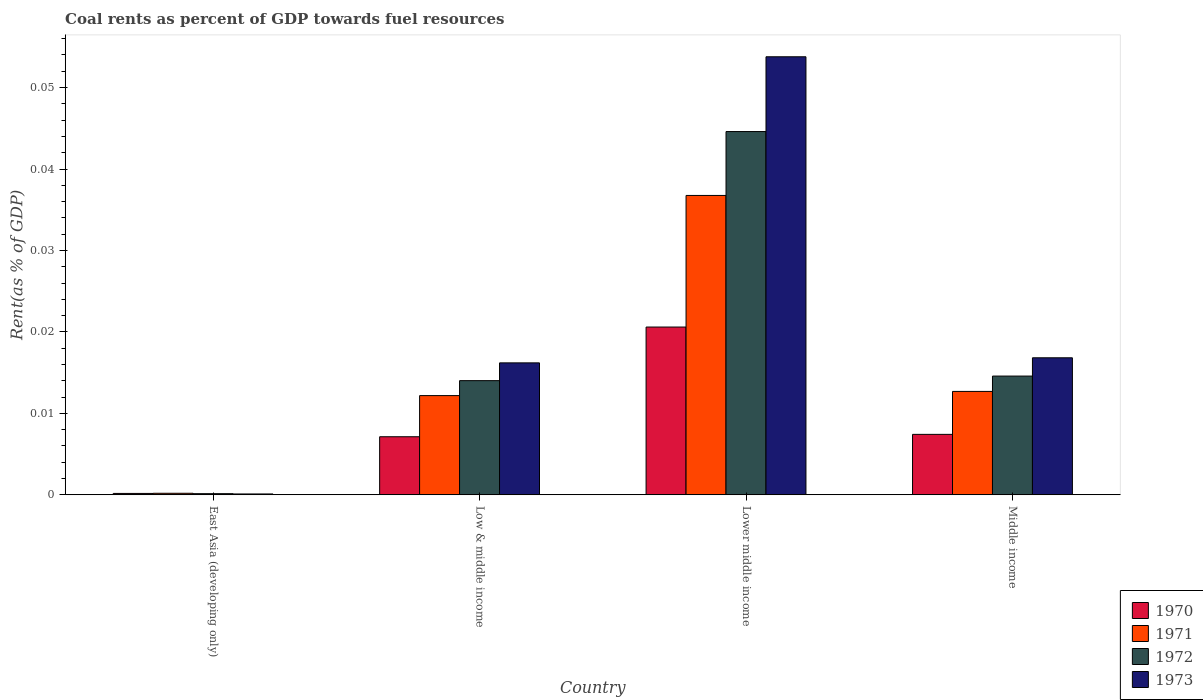Are the number of bars on each tick of the X-axis equal?
Offer a very short reply. Yes. How many bars are there on the 2nd tick from the left?
Keep it short and to the point. 4. How many bars are there on the 2nd tick from the right?
Provide a succinct answer. 4. What is the label of the 4th group of bars from the left?
Keep it short and to the point. Middle income. In how many cases, is the number of bars for a given country not equal to the number of legend labels?
Your answer should be compact. 0. What is the coal rent in 1971 in Middle income?
Give a very brief answer. 0.01. Across all countries, what is the maximum coal rent in 1972?
Ensure brevity in your answer.  0.04. Across all countries, what is the minimum coal rent in 1970?
Your answer should be compact. 0. In which country was the coal rent in 1971 maximum?
Your response must be concise. Lower middle income. In which country was the coal rent in 1971 minimum?
Offer a terse response. East Asia (developing only). What is the total coal rent in 1970 in the graph?
Provide a succinct answer. 0.04. What is the difference between the coal rent in 1973 in Low & middle income and that in Lower middle income?
Provide a short and direct response. -0.04. What is the difference between the coal rent in 1970 in Lower middle income and the coal rent in 1973 in Middle income?
Provide a short and direct response. 0. What is the average coal rent in 1972 per country?
Give a very brief answer. 0.02. What is the difference between the coal rent of/in 1972 and coal rent of/in 1971 in Low & middle income?
Keep it short and to the point. 0. What is the ratio of the coal rent in 1972 in East Asia (developing only) to that in Lower middle income?
Offer a very short reply. 0. What is the difference between the highest and the second highest coal rent in 1972?
Your response must be concise. 0.03. What is the difference between the highest and the lowest coal rent in 1972?
Provide a succinct answer. 0.04. In how many countries, is the coal rent in 1971 greater than the average coal rent in 1971 taken over all countries?
Keep it short and to the point. 1. What does the 3rd bar from the right in Middle income represents?
Make the answer very short. 1971. How many bars are there?
Provide a succinct answer. 16. Are all the bars in the graph horizontal?
Give a very brief answer. No. What is the difference between two consecutive major ticks on the Y-axis?
Make the answer very short. 0.01. Are the values on the major ticks of Y-axis written in scientific E-notation?
Keep it short and to the point. No. Does the graph contain any zero values?
Your answer should be compact. No. Where does the legend appear in the graph?
Give a very brief answer. Bottom right. What is the title of the graph?
Provide a short and direct response. Coal rents as percent of GDP towards fuel resources. Does "2010" appear as one of the legend labels in the graph?
Keep it short and to the point. No. What is the label or title of the Y-axis?
Give a very brief answer. Rent(as % of GDP). What is the Rent(as % of GDP) in 1970 in East Asia (developing only)?
Make the answer very short. 0. What is the Rent(as % of GDP) of 1971 in East Asia (developing only)?
Keep it short and to the point. 0. What is the Rent(as % of GDP) of 1972 in East Asia (developing only)?
Give a very brief answer. 0. What is the Rent(as % of GDP) in 1973 in East Asia (developing only)?
Provide a succinct answer. 0. What is the Rent(as % of GDP) of 1970 in Low & middle income?
Your response must be concise. 0.01. What is the Rent(as % of GDP) in 1971 in Low & middle income?
Make the answer very short. 0.01. What is the Rent(as % of GDP) in 1972 in Low & middle income?
Make the answer very short. 0.01. What is the Rent(as % of GDP) in 1973 in Low & middle income?
Give a very brief answer. 0.02. What is the Rent(as % of GDP) of 1970 in Lower middle income?
Offer a very short reply. 0.02. What is the Rent(as % of GDP) in 1971 in Lower middle income?
Offer a very short reply. 0.04. What is the Rent(as % of GDP) of 1972 in Lower middle income?
Your answer should be compact. 0.04. What is the Rent(as % of GDP) of 1973 in Lower middle income?
Keep it short and to the point. 0.05. What is the Rent(as % of GDP) of 1970 in Middle income?
Your answer should be compact. 0.01. What is the Rent(as % of GDP) in 1971 in Middle income?
Provide a short and direct response. 0.01. What is the Rent(as % of GDP) of 1972 in Middle income?
Give a very brief answer. 0.01. What is the Rent(as % of GDP) of 1973 in Middle income?
Your answer should be compact. 0.02. Across all countries, what is the maximum Rent(as % of GDP) in 1970?
Your response must be concise. 0.02. Across all countries, what is the maximum Rent(as % of GDP) of 1971?
Your answer should be compact. 0.04. Across all countries, what is the maximum Rent(as % of GDP) of 1972?
Provide a succinct answer. 0.04. Across all countries, what is the maximum Rent(as % of GDP) in 1973?
Ensure brevity in your answer.  0.05. Across all countries, what is the minimum Rent(as % of GDP) of 1970?
Your answer should be compact. 0. Across all countries, what is the minimum Rent(as % of GDP) of 1971?
Give a very brief answer. 0. Across all countries, what is the minimum Rent(as % of GDP) in 1972?
Your answer should be compact. 0. Across all countries, what is the minimum Rent(as % of GDP) in 1973?
Your answer should be compact. 0. What is the total Rent(as % of GDP) of 1970 in the graph?
Offer a very short reply. 0.04. What is the total Rent(as % of GDP) of 1971 in the graph?
Give a very brief answer. 0.06. What is the total Rent(as % of GDP) in 1972 in the graph?
Provide a short and direct response. 0.07. What is the total Rent(as % of GDP) in 1973 in the graph?
Your answer should be compact. 0.09. What is the difference between the Rent(as % of GDP) of 1970 in East Asia (developing only) and that in Low & middle income?
Make the answer very short. -0.01. What is the difference between the Rent(as % of GDP) in 1971 in East Asia (developing only) and that in Low & middle income?
Offer a very short reply. -0.01. What is the difference between the Rent(as % of GDP) in 1972 in East Asia (developing only) and that in Low & middle income?
Provide a short and direct response. -0.01. What is the difference between the Rent(as % of GDP) in 1973 in East Asia (developing only) and that in Low & middle income?
Make the answer very short. -0.02. What is the difference between the Rent(as % of GDP) of 1970 in East Asia (developing only) and that in Lower middle income?
Provide a short and direct response. -0.02. What is the difference between the Rent(as % of GDP) in 1971 in East Asia (developing only) and that in Lower middle income?
Provide a short and direct response. -0.04. What is the difference between the Rent(as % of GDP) of 1972 in East Asia (developing only) and that in Lower middle income?
Offer a terse response. -0.04. What is the difference between the Rent(as % of GDP) in 1973 in East Asia (developing only) and that in Lower middle income?
Give a very brief answer. -0.05. What is the difference between the Rent(as % of GDP) of 1970 in East Asia (developing only) and that in Middle income?
Keep it short and to the point. -0.01. What is the difference between the Rent(as % of GDP) in 1971 in East Asia (developing only) and that in Middle income?
Provide a succinct answer. -0.01. What is the difference between the Rent(as % of GDP) in 1972 in East Asia (developing only) and that in Middle income?
Provide a succinct answer. -0.01. What is the difference between the Rent(as % of GDP) of 1973 in East Asia (developing only) and that in Middle income?
Your response must be concise. -0.02. What is the difference between the Rent(as % of GDP) in 1970 in Low & middle income and that in Lower middle income?
Keep it short and to the point. -0.01. What is the difference between the Rent(as % of GDP) of 1971 in Low & middle income and that in Lower middle income?
Your answer should be compact. -0.02. What is the difference between the Rent(as % of GDP) in 1972 in Low & middle income and that in Lower middle income?
Ensure brevity in your answer.  -0.03. What is the difference between the Rent(as % of GDP) in 1973 in Low & middle income and that in Lower middle income?
Your answer should be very brief. -0.04. What is the difference between the Rent(as % of GDP) in 1970 in Low & middle income and that in Middle income?
Keep it short and to the point. -0. What is the difference between the Rent(as % of GDP) of 1971 in Low & middle income and that in Middle income?
Ensure brevity in your answer.  -0. What is the difference between the Rent(as % of GDP) in 1972 in Low & middle income and that in Middle income?
Make the answer very short. -0. What is the difference between the Rent(as % of GDP) of 1973 in Low & middle income and that in Middle income?
Your answer should be very brief. -0. What is the difference between the Rent(as % of GDP) in 1970 in Lower middle income and that in Middle income?
Provide a short and direct response. 0.01. What is the difference between the Rent(as % of GDP) of 1971 in Lower middle income and that in Middle income?
Provide a succinct answer. 0.02. What is the difference between the Rent(as % of GDP) of 1972 in Lower middle income and that in Middle income?
Provide a succinct answer. 0.03. What is the difference between the Rent(as % of GDP) of 1973 in Lower middle income and that in Middle income?
Offer a terse response. 0.04. What is the difference between the Rent(as % of GDP) of 1970 in East Asia (developing only) and the Rent(as % of GDP) of 1971 in Low & middle income?
Your answer should be very brief. -0.01. What is the difference between the Rent(as % of GDP) in 1970 in East Asia (developing only) and the Rent(as % of GDP) in 1972 in Low & middle income?
Provide a short and direct response. -0.01. What is the difference between the Rent(as % of GDP) of 1970 in East Asia (developing only) and the Rent(as % of GDP) of 1973 in Low & middle income?
Provide a succinct answer. -0.02. What is the difference between the Rent(as % of GDP) of 1971 in East Asia (developing only) and the Rent(as % of GDP) of 1972 in Low & middle income?
Your answer should be very brief. -0.01. What is the difference between the Rent(as % of GDP) in 1971 in East Asia (developing only) and the Rent(as % of GDP) in 1973 in Low & middle income?
Provide a short and direct response. -0.02. What is the difference between the Rent(as % of GDP) in 1972 in East Asia (developing only) and the Rent(as % of GDP) in 1973 in Low & middle income?
Your answer should be compact. -0.02. What is the difference between the Rent(as % of GDP) in 1970 in East Asia (developing only) and the Rent(as % of GDP) in 1971 in Lower middle income?
Give a very brief answer. -0.04. What is the difference between the Rent(as % of GDP) in 1970 in East Asia (developing only) and the Rent(as % of GDP) in 1972 in Lower middle income?
Provide a short and direct response. -0.04. What is the difference between the Rent(as % of GDP) in 1970 in East Asia (developing only) and the Rent(as % of GDP) in 1973 in Lower middle income?
Ensure brevity in your answer.  -0.05. What is the difference between the Rent(as % of GDP) of 1971 in East Asia (developing only) and the Rent(as % of GDP) of 1972 in Lower middle income?
Your response must be concise. -0.04. What is the difference between the Rent(as % of GDP) of 1971 in East Asia (developing only) and the Rent(as % of GDP) of 1973 in Lower middle income?
Give a very brief answer. -0.05. What is the difference between the Rent(as % of GDP) of 1972 in East Asia (developing only) and the Rent(as % of GDP) of 1973 in Lower middle income?
Your response must be concise. -0.05. What is the difference between the Rent(as % of GDP) of 1970 in East Asia (developing only) and the Rent(as % of GDP) of 1971 in Middle income?
Your answer should be very brief. -0.01. What is the difference between the Rent(as % of GDP) of 1970 in East Asia (developing only) and the Rent(as % of GDP) of 1972 in Middle income?
Provide a short and direct response. -0.01. What is the difference between the Rent(as % of GDP) in 1970 in East Asia (developing only) and the Rent(as % of GDP) in 1973 in Middle income?
Ensure brevity in your answer.  -0.02. What is the difference between the Rent(as % of GDP) of 1971 in East Asia (developing only) and the Rent(as % of GDP) of 1972 in Middle income?
Your response must be concise. -0.01. What is the difference between the Rent(as % of GDP) in 1971 in East Asia (developing only) and the Rent(as % of GDP) in 1973 in Middle income?
Ensure brevity in your answer.  -0.02. What is the difference between the Rent(as % of GDP) in 1972 in East Asia (developing only) and the Rent(as % of GDP) in 1973 in Middle income?
Provide a succinct answer. -0.02. What is the difference between the Rent(as % of GDP) of 1970 in Low & middle income and the Rent(as % of GDP) of 1971 in Lower middle income?
Ensure brevity in your answer.  -0.03. What is the difference between the Rent(as % of GDP) in 1970 in Low & middle income and the Rent(as % of GDP) in 1972 in Lower middle income?
Provide a succinct answer. -0.04. What is the difference between the Rent(as % of GDP) of 1970 in Low & middle income and the Rent(as % of GDP) of 1973 in Lower middle income?
Offer a very short reply. -0.05. What is the difference between the Rent(as % of GDP) of 1971 in Low & middle income and the Rent(as % of GDP) of 1972 in Lower middle income?
Your answer should be compact. -0.03. What is the difference between the Rent(as % of GDP) in 1971 in Low & middle income and the Rent(as % of GDP) in 1973 in Lower middle income?
Your answer should be compact. -0.04. What is the difference between the Rent(as % of GDP) of 1972 in Low & middle income and the Rent(as % of GDP) of 1973 in Lower middle income?
Ensure brevity in your answer.  -0.04. What is the difference between the Rent(as % of GDP) of 1970 in Low & middle income and the Rent(as % of GDP) of 1971 in Middle income?
Give a very brief answer. -0.01. What is the difference between the Rent(as % of GDP) of 1970 in Low & middle income and the Rent(as % of GDP) of 1972 in Middle income?
Keep it short and to the point. -0.01. What is the difference between the Rent(as % of GDP) of 1970 in Low & middle income and the Rent(as % of GDP) of 1973 in Middle income?
Offer a terse response. -0.01. What is the difference between the Rent(as % of GDP) of 1971 in Low & middle income and the Rent(as % of GDP) of 1972 in Middle income?
Your answer should be compact. -0. What is the difference between the Rent(as % of GDP) of 1971 in Low & middle income and the Rent(as % of GDP) of 1973 in Middle income?
Provide a succinct answer. -0. What is the difference between the Rent(as % of GDP) of 1972 in Low & middle income and the Rent(as % of GDP) of 1973 in Middle income?
Your response must be concise. -0. What is the difference between the Rent(as % of GDP) in 1970 in Lower middle income and the Rent(as % of GDP) in 1971 in Middle income?
Ensure brevity in your answer.  0.01. What is the difference between the Rent(as % of GDP) of 1970 in Lower middle income and the Rent(as % of GDP) of 1972 in Middle income?
Your response must be concise. 0.01. What is the difference between the Rent(as % of GDP) of 1970 in Lower middle income and the Rent(as % of GDP) of 1973 in Middle income?
Make the answer very short. 0. What is the difference between the Rent(as % of GDP) of 1971 in Lower middle income and the Rent(as % of GDP) of 1972 in Middle income?
Your answer should be very brief. 0.02. What is the difference between the Rent(as % of GDP) of 1971 in Lower middle income and the Rent(as % of GDP) of 1973 in Middle income?
Provide a short and direct response. 0.02. What is the difference between the Rent(as % of GDP) of 1972 in Lower middle income and the Rent(as % of GDP) of 1973 in Middle income?
Offer a very short reply. 0.03. What is the average Rent(as % of GDP) in 1970 per country?
Give a very brief answer. 0.01. What is the average Rent(as % of GDP) of 1971 per country?
Your answer should be very brief. 0.02. What is the average Rent(as % of GDP) in 1972 per country?
Offer a very short reply. 0.02. What is the average Rent(as % of GDP) of 1973 per country?
Provide a short and direct response. 0.02. What is the difference between the Rent(as % of GDP) in 1970 and Rent(as % of GDP) in 1971 in East Asia (developing only)?
Provide a succinct answer. -0. What is the difference between the Rent(as % of GDP) in 1970 and Rent(as % of GDP) in 1972 in East Asia (developing only)?
Give a very brief answer. 0. What is the difference between the Rent(as % of GDP) in 1970 and Rent(as % of GDP) in 1973 in East Asia (developing only)?
Give a very brief answer. 0. What is the difference between the Rent(as % of GDP) in 1971 and Rent(as % of GDP) in 1973 in East Asia (developing only)?
Your answer should be very brief. 0. What is the difference between the Rent(as % of GDP) in 1972 and Rent(as % of GDP) in 1973 in East Asia (developing only)?
Make the answer very short. 0. What is the difference between the Rent(as % of GDP) of 1970 and Rent(as % of GDP) of 1971 in Low & middle income?
Ensure brevity in your answer.  -0.01. What is the difference between the Rent(as % of GDP) in 1970 and Rent(as % of GDP) in 1972 in Low & middle income?
Your response must be concise. -0.01. What is the difference between the Rent(as % of GDP) of 1970 and Rent(as % of GDP) of 1973 in Low & middle income?
Your response must be concise. -0.01. What is the difference between the Rent(as % of GDP) of 1971 and Rent(as % of GDP) of 1972 in Low & middle income?
Offer a very short reply. -0. What is the difference between the Rent(as % of GDP) in 1971 and Rent(as % of GDP) in 1973 in Low & middle income?
Provide a succinct answer. -0. What is the difference between the Rent(as % of GDP) in 1972 and Rent(as % of GDP) in 1973 in Low & middle income?
Make the answer very short. -0. What is the difference between the Rent(as % of GDP) in 1970 and Rent(as % of GDP) in 1971 in Lower middle income?
Keep it short and to the point. -0.02. What is the difference between the Rent(as % of GDP) of 1970 and Rent(as % of GDP) of 1972 in Lower middle income?
Offer a terse response. -0.02. What is the difference between the Rent(as % of GDP) of 1970 and Rent(as % of GDP) of 1973 in Lower middle income?
Give a very brief answer. -0.03. What is the difference between the Rent(as % of GDP) in 1971 and Rent(as % of GDP) in 1972 in Lower middle income?
Your answer should be very brief. -0.01. What is the difference between the Rent(as % of GDP) of 1971 and Rent(as % of GDP) of 1973 in Lower middle income?
Your answer should be compact. -0.02. What is the difference between the Rent(as % of GDP) of 1972 and Rent(as % of GDP) of 1973 in Lower middle income?
Ensure brevity in your answer.  -0.01. What is the difference between the Rent(as % of GDP) in 1970 and Rent(as % of GDP) in 1971 in Middle income?
Your answer should be very brief. -0.01. What is the difference between the Rent(as % of GDP) of 1970 and Rent(as % of GDP) of 1972 in Middle income?
Your answer should be compact. -0.01. What is the difference between the Rent(as % of GDP) in 1970 and Rent(as % of GDP) in 1973 in Middle income?
Make the answer very short. -0.01. What is the difference between the Rent(as % of GDP) in 1971 and Rent(as % of GDP) in 1972 in Middle income?
Provide a short and direct response. -0. What is the difference between the Rent(as % of GDP) in 1971 and Rent(as % of GDP) in 1973 in Middle income?
Make the answer very short. -0. What is the difference between the Rent(as % of GDP) in 1972 and Rent(as % of GDP) in 1973 in Middle income?
Offer a terse response. -0. What is the ratio of the Rent(as % of GDP) in 1970 in East Asia (developing only) to that in Low & middle income?
Your answer should be compact. 0.02. What is the ratio of the Rent(as % of GDP) of 1971 in East Asia (developing only) to that in Low & middle income?
Offer a very short reply. 0.02. What is the ratio of the Rent(as % of GDP) in 1972 in East Asia (developing only) to that in Low & middle income?
Give a very brief answer. 0.01. What is the ratio of the Rent(as % of GDP) in 1973 in East Asia (developing only) to that in Low & middle income?
Your answer should be very brief. 0.01. What is the ratio of the Rent(as % of GDP) of 1970 in East Asia (developing only) to that in Lower middle income?
Ensure brevity in your answer.  0.01. What is the ratio of the Rent(as % of GDP) of 1971 in East Asia (developing only) to that in Lower middle income?
Make the answer very short. 0.01. What is the ratio of the Rent(as % of GDP) in 1972 in East Asia (developing only) to that in Lower middle income?
Your response must be concise. 0. What is the ratio of the Rent(as % of GDP) in 1973 in East Asia (developing only) to that in Lower middle income?
Your answer should be compact. 0. What is the ratio of the Rent(as % of GDP) in 1970 in East Asia (developing only) to that in Middle income?
Your response must be concise. 0.02. What is the ratio of the Rent(as % of GDP) of 1971 in East Asia (developing only) to that in Middle income?
Your answer should be compact. 0.01. What is the ratio of the Rent(as % of GDP) of 1972 in East Asia (developing only) to that in Middle income?
Offer a very short reply. 0.01. What is the ratio of the Rent(as % of GDP) of 1973 in East Asia (developing only) to that in Middle income?
Provide a short and direct response. 0.01. What is the ratio of the Rent(as % of GDP) of 1970 in Low & middle income to that in Lower middle income?
Your answer should be compact. 0.35. What is the ratio of the Rent(as % of GDP) in 1971 in Low & middle income to that in Lower middle income?
Your response must be concise. 0.33. What is the ratio of the Rent(as % of GDP) in 1972 in Low & middle income to that in Lower middle income?
Give a very brief answer. 0.31. What is the ratio of the Rent(as % of GDP) of 1973 in Low & middle income to that in Lower middle income?
Make the answer very short. 0.3. What is the ratio of the Rent(as % of GDP) in 1970 in Low & middle income to that in Middle income?
Offer a very short reply. 0.96. What is the ratio of the Rent(as % of GDP) of 1971 in Low & middle income to that in Middle income?
Ensure brevity in your answer.  0.96. What is the ratio of the Rent(as % of GDP) in 1972 in Low & middle income to that in Middle income?
Ensure brevity in your answer.  0.96. What is the ratio of the Rent(as % of GDP) of 1973 in Low & middle income to that in Middle income?
Keep it short and to the point. 0.96. What is the ratio of the Rent(as % of GDP) in 1970 in Lower middle income to that in Middle income?
Your answer should be compact. 2.78. What is the ratio of the Rent(as % of GDP) in 1971 in Lower middle income to that in Middle income?
Keep it short and to the point. 2.9. What is the ratio of the Rent(as % of GDP) in 1972 in Lower middle income to that in Middle income?
Make the answer very short. 3.06. What is the ratio of the Rent(as % of GDP) of 1973 in Lower middle income to that in Middle income?
Make the answer very short. 3.2. What is the difference between the highest and the second highest Rent(as % of GDP) in 1970?
Provide a short and direct response. 0.01. What is the difference between the highest and the second highest Rent(as % of GDP) of 1971?
Your answer should be very brief. 0.02. What is the difference between the highest and the second highest Rent(as % of GDP) in 1973?
Your answer should be very brief. 0.04. What is the difference between the highest and the lowest Rent(as % of GDP) in 1970?
Your response must be concise. 0.02. What is the difference between the highest and the lowest Rent(as % of GDP) in 1971?
Give a very brief answer. 0.04. What is the difference between the highest and the lowest Rent(as % of GDP) of 1972?
Give a very brief answer. 0.04. What is the difference between the highest and the lowest Rent(as % of GDP) in 1973?
Give a very brief answer. 0.05. 